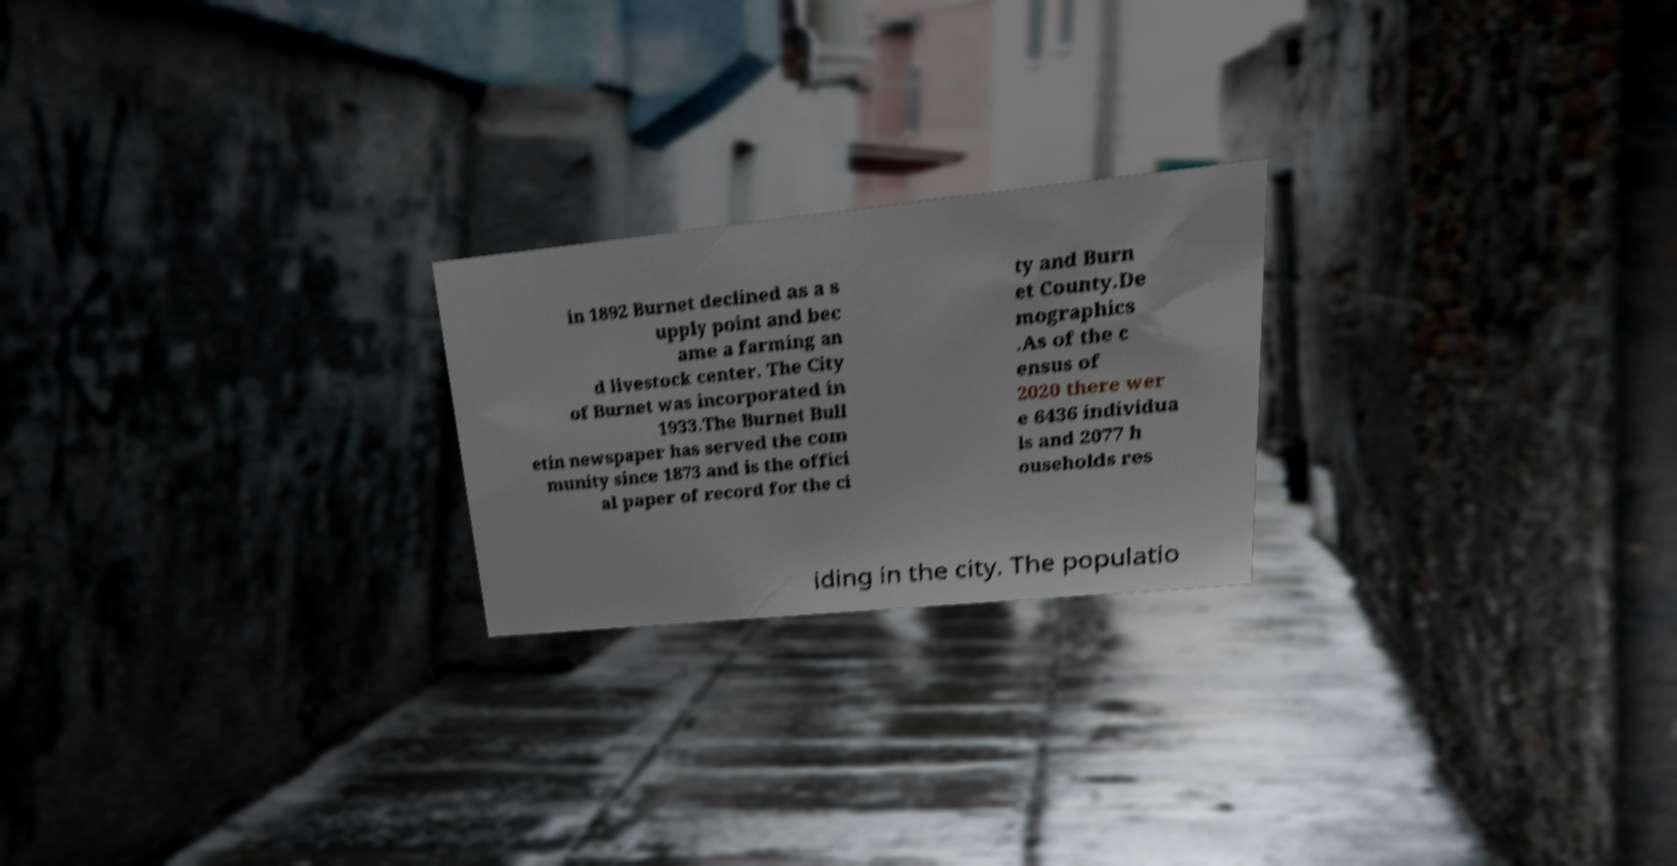For documentation purposes, I need the text within this image transcribed. Could you provide that? in 1892 Burnet declined as a s upply point and bec ame a farming an d livestock center. The City of Burnet was incorporated in 1933.The Burnet Bull etin newspaper has served the com munity since 1873 and is the offici al paper of record for the ci ty and Burn et County.De mographics .As of the c ensus of 2020 there wer e 6436 individua ls and 2077 h ouseholds res iding in the city. The populatio 